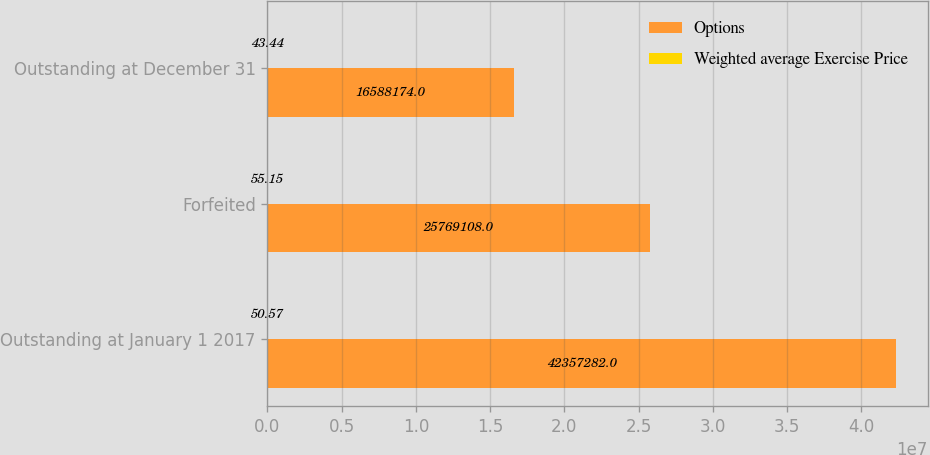Convert chart to OTSL. <chart><loc_0><loc_0><loc_500><loc_500><stacked_bar_chart><ecel><fcel>Outstanding at January 1 2017<fcel>Forfeited<fcel>Outstanding at December 31<nl><fcel>Options<fcel>4.23573e+07<fcel>2.57691e+07<fcel>1.65882e+07<nl><fcel>Weighted average Exercise Price<fcel>50.57<fcel>55.15<fcel>43.44<nl></chart> 